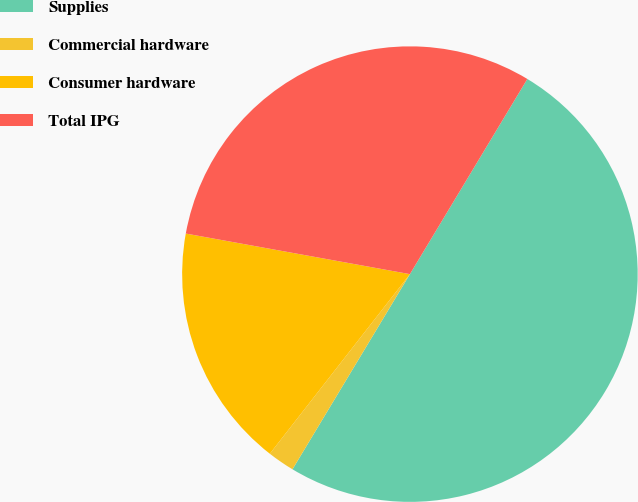Convert chart to OTSL. <chart><loc_0><loc_0><loc_500><loc_500><pie_chart><fcel>Supplies<fcel>Commercial hardware<fcel>Consumer hardware<fcel>Total IPG<nl><fcel>50.0%<fcel>1.92%<fcel>17.31%<fcel>30.77%<nl></chart> 